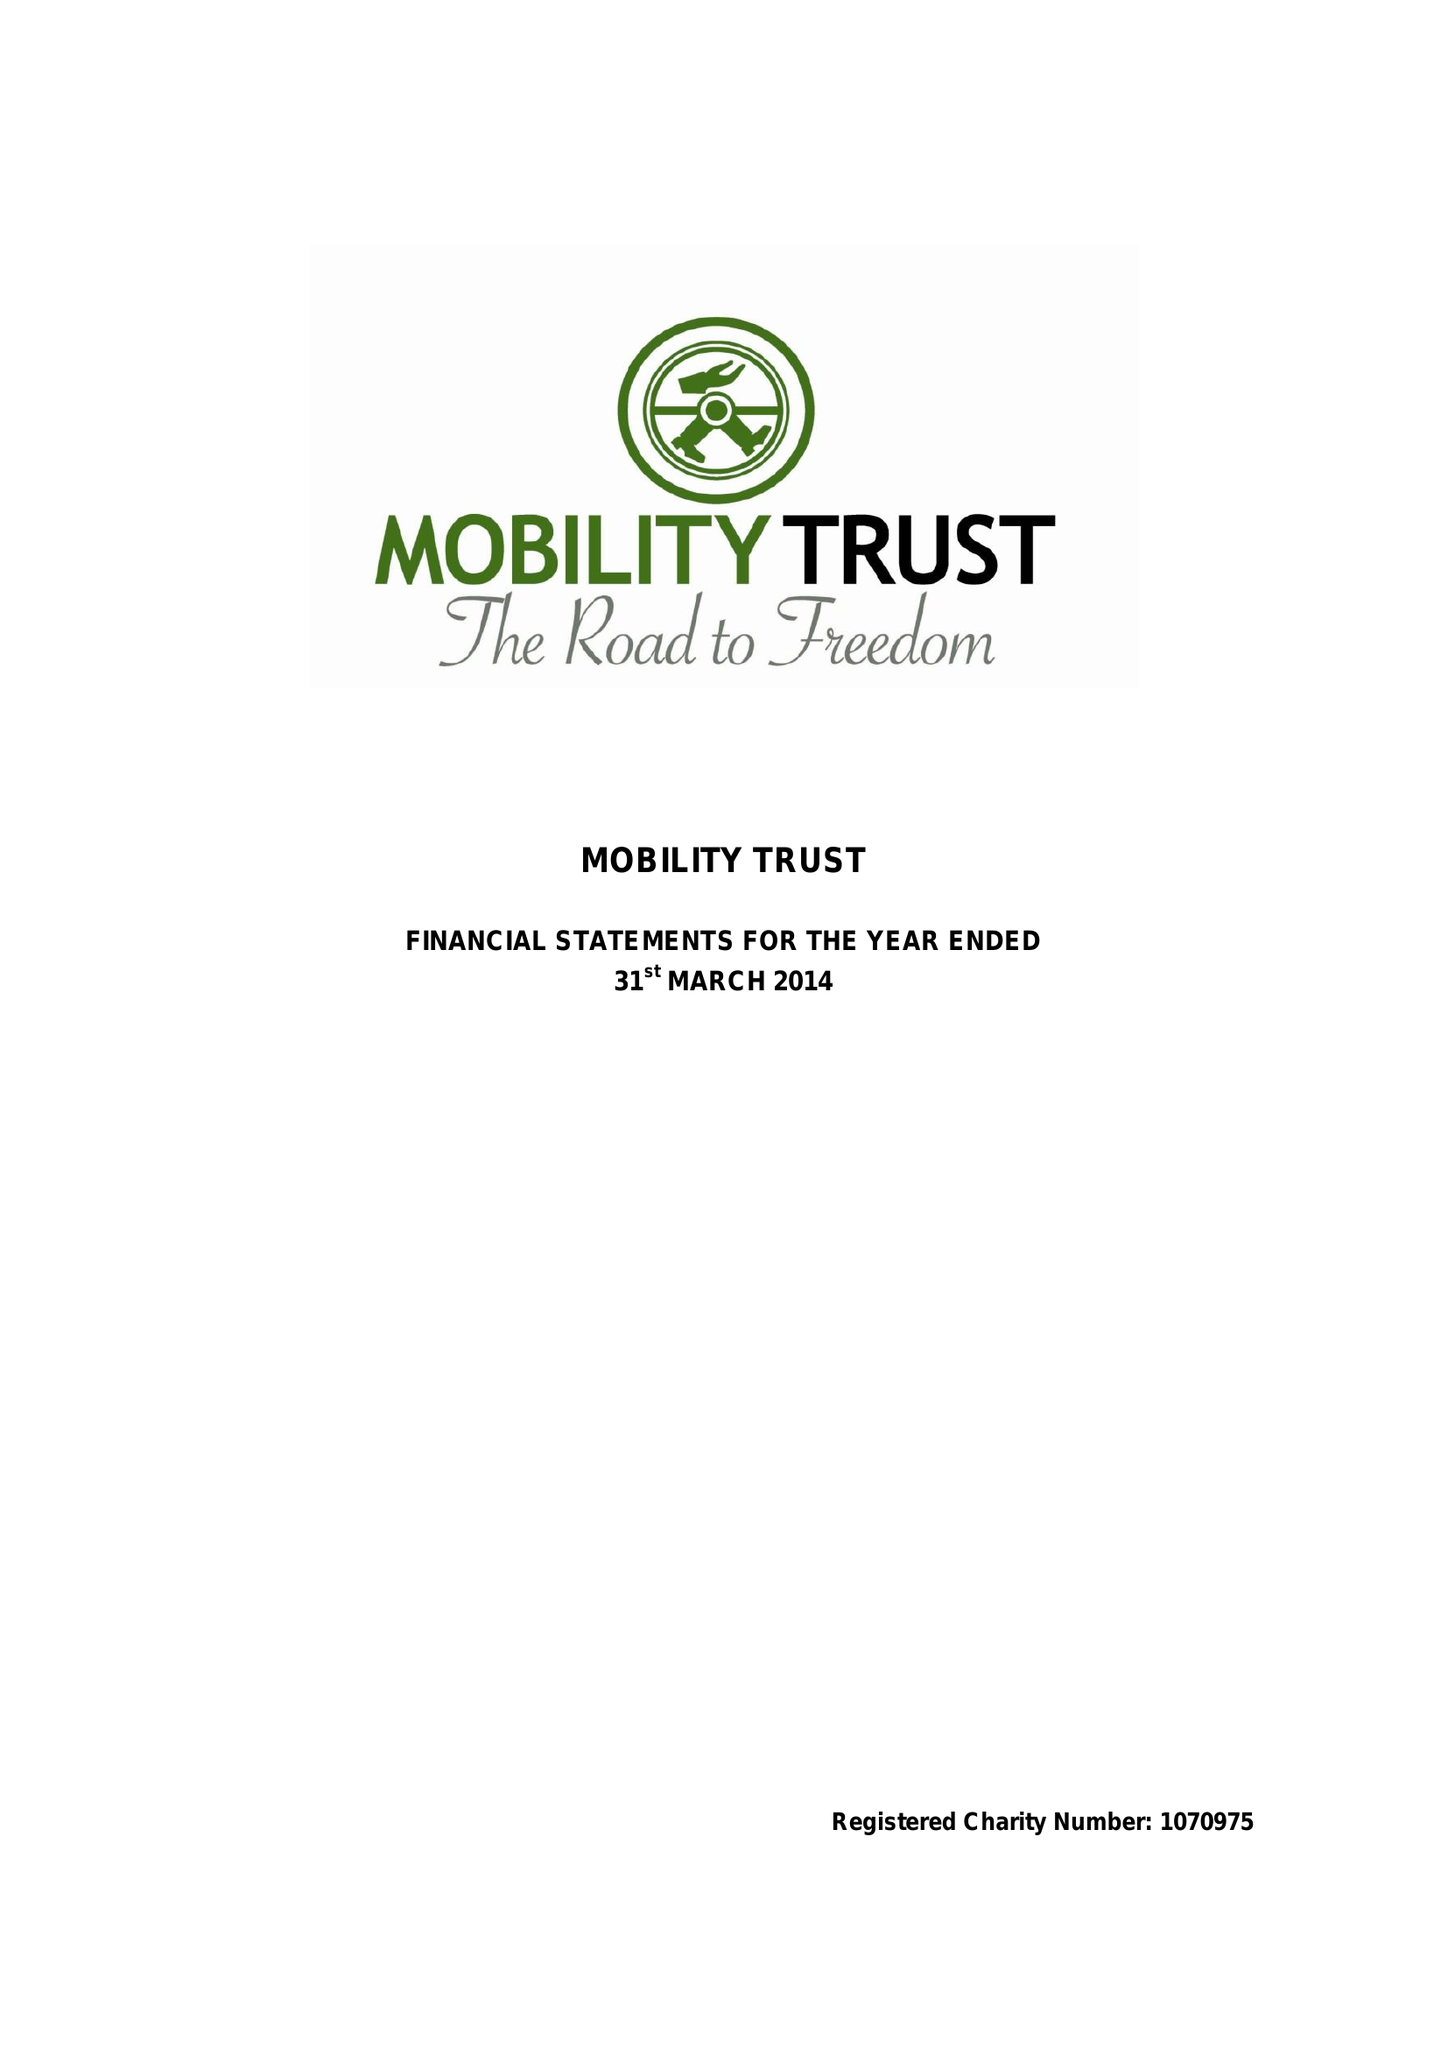What is the value for the income_annually_in_british_pounds?
Answer the question using a single word or phrase. 304422.00 